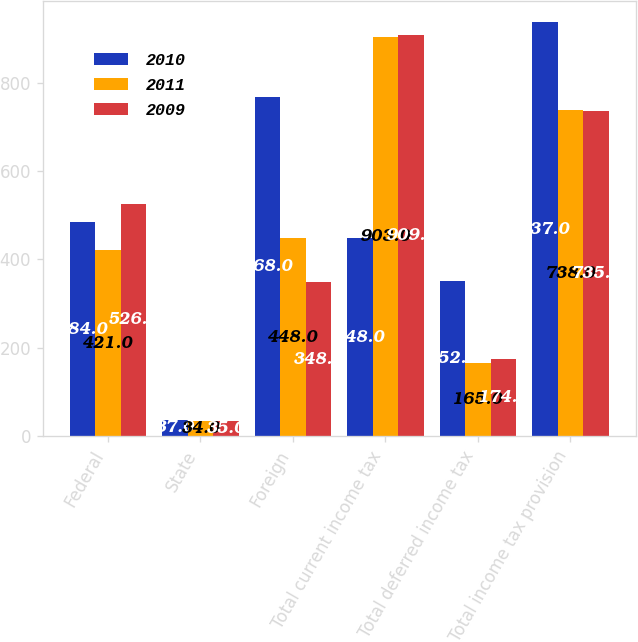Convert chart. <chart><loc_0><loc_0><loc_500><loc_500><stacked_bar_chart><ecel><fcel>Federal<fcel>State<fcel>Foreign<fcel>Total current income tax<fcel>Total deferred income tax<fcel>Total income tax provision<nl><fcel>2010<fcel>484<fcel>37<fcel>768<fcel>448<fcel>352<fcel>937<nl><fcel>2011<fcel>421<fcel>34<fcel>448<fcel>903<fcel>165<fcel>738<nl><fcel>2009<fcel>526<fcel>35<fcel>348<fcel>909<fcel>174<fcel>735<nl></chart> 